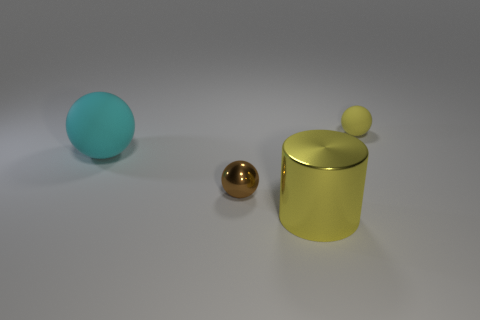Subtract all large spheres. How many spheres are left? 2 Add 3 big cyan metal spheres. How many objects exist? 7 Subtract all yellow spheres. How many spheres are left? 2 Subtract all balls. How many objects are left? 1 Subtract all brown balls. Subtract all yellow cylinders. How many balls are left? 2 Add 2 cyan matte spheres. How many cyan matte spheres are left? 3 Add 4 yellow metallic things. How many yellow metallic things exist? 5 Subtract 1 brown spheres. How many objects are left? 3 Subtract all red cubes. How many cyan spheres are left? 1 Subtract all tiny cyan rubber balls. Subtract all large cyan spheres. How many objects are left? 3 